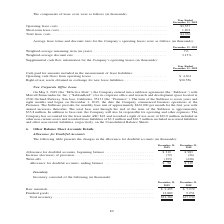According to A10 Networks's financial document, What data is covered by the table? Allowance for Doubtful Accounts. The document states: "Allowance for Doubtful Accounts..." Also, What is the allowance for doubtful accounts as at December 31, 2019? According to the financial document, $52 (in thousands). The relevant text states: "lowance for doubtful accounts, ending balance . $ 52 $ 319..." Also, What is the allowance for doubtful accounts as at December 31, 2018? According to the financial document, $319 (in thousands). The relevant text states: "ance for doubtful accounts, beginning balance . $ 319 $ 983 Increase (decrease) of provision. . (72) (26) Write-offs . (195) (638)..." Also, can you calculate: What is the total allowance for doubtful accounts, ending balance between 2018 and 2019? Based on the calculation: 52+319, the result is 371 (in thousands). This is based on the information: "ance for doubtful accounts, beginning balance . $ 319 $ 983 Increase (decrease) of provision. . (72) (26) Write-offs . (195) (638) lowance for doubtful accounts, ending balance . $ 52 $ 319..." The key data points involved are: 319, 52. Also, can you calculate: What is the sum of the write-offs in 2018 and 2019? Based on the calculation: 195 + 638 , the result is 833 (in thousands). This is based on the information: "se) of provision. . (72) (26) Write-offs . (195) (638) decrease) of provision. . (72) (26) Write-offs . (195) (638)..." The key data points involved are: 195, 638. Also, can you calculate: What is the percentage change in allowance for doubtful accounts, ending balance between 2018 and 2019? To answer this question, I need to perform calculations using the financial data. The calculation is: (52 - 319)/319 , which equals -83.7 (percentage). This is based on the information: "ance for doubtful accounts, beginning balance . $ 319 $ 983 Increase (decrease) of provision. . (72) (26) Write-offs . (195) (638) lowance for doubtful accounts, ending balance . $ 52 $ 319..." The key data points involved are: 319, 52. 